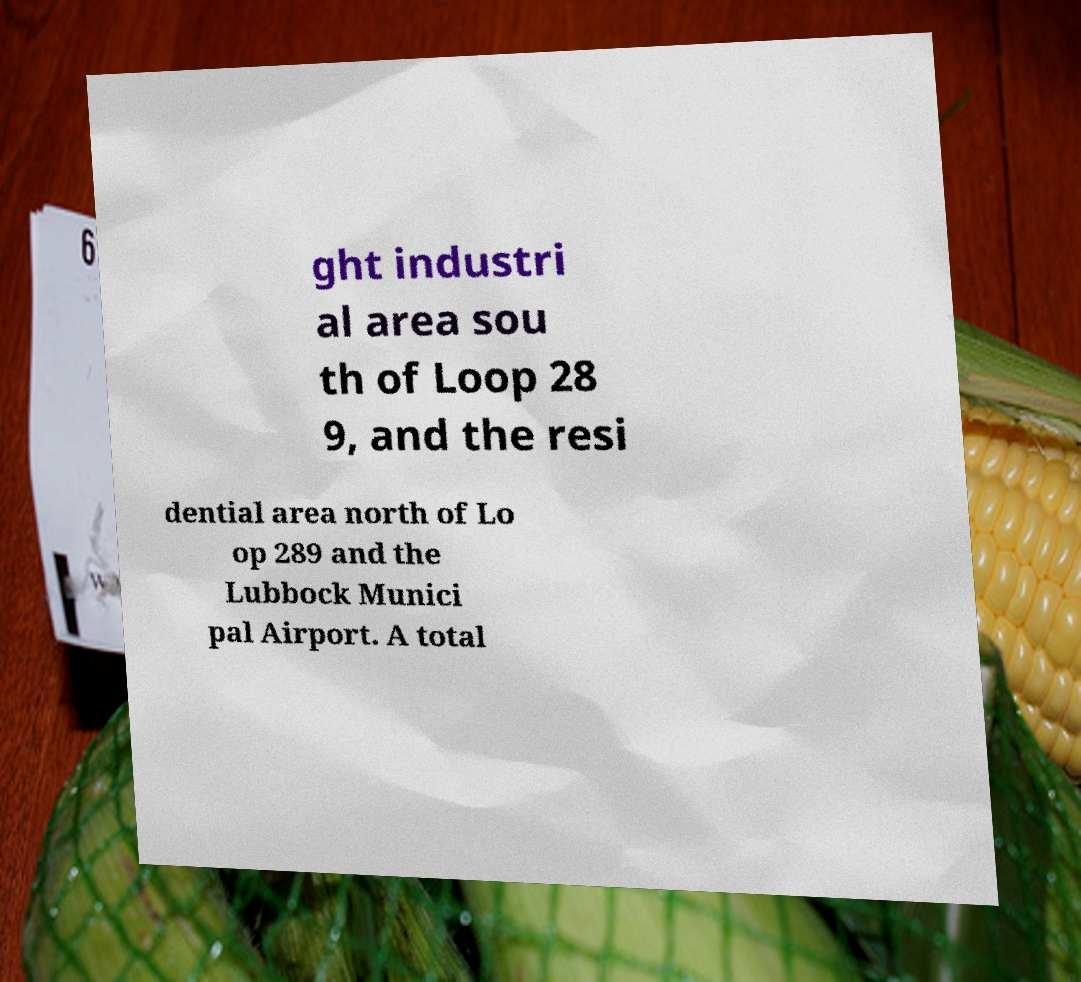Could you extract and type out the text from this image? ght industri al area sou th of Loop 28 9, and the resi dential area north of Lo op 289 and the Lubbock Munici pal Airport. A total 